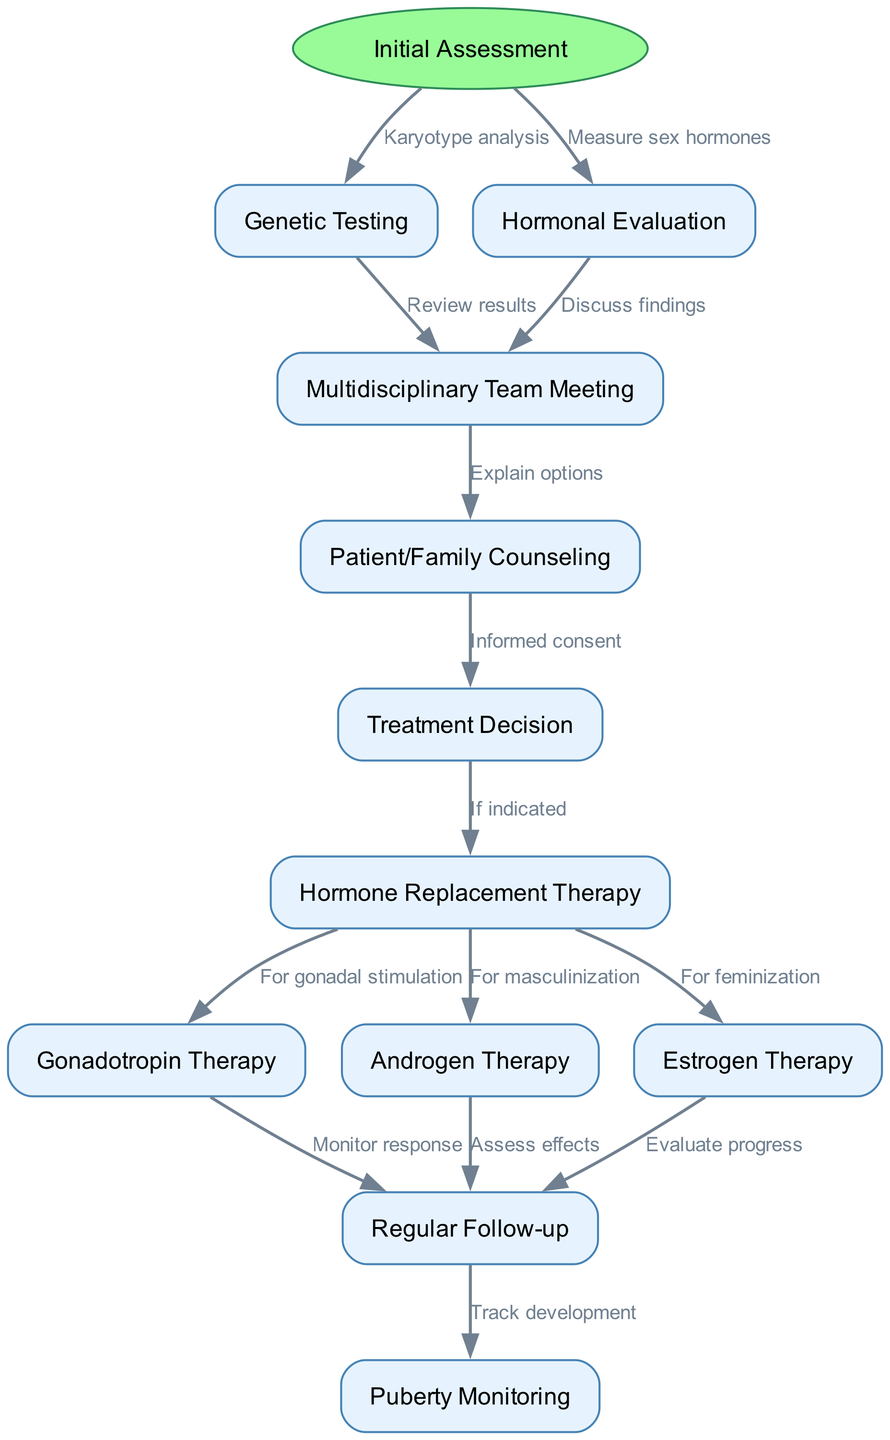What is the starting point of the clinical pathway? The starting point is listed in the diagram as "Initial Assessment," which is the first node and directs toward further evaluations.
Answer: Initial Assessment How many nodes are present in the diagram? By counting the nodes listed in the diagram, there are a total of 11 nodes, including the start node and all the subsequent steps.
Answer: 11 What is the connection between "Genetic Testing" and "Multidisciplinary Team Meeting"? The edge between these two nodes is labeled "Review results," showing a directional flow from genetic testing to the multidisciplinary team meeting.
Answer: Review results What type of therapy is indicated after the "Treatment Decision"? From the "Treatment Decision" node, the diagram shows arrows leading to three types of therapies: Gonadotropin Therapy, Androgen Therapy, and Estrogen Therapy, indicating possible therapies based on individual needs.
Answer: Hormone Replacement Therapy What is the last step in the clinical pathway? The final step listed in the diagram is "Puberty Monitoring," which follows the "Regular Follow-up" and signifies continuous tracking of developmental changes.
Answer: Puberty Monitoring How many types of hormone therapy are indicated in the pathway? The diagram outlines three types of hormone therapy following "Hormone Replacement Therapy": Gonadotropin Therapy, Androgen Therapy, and Estrogen Therapy. Thus, the total is three distinct types.
Answer: 3 What procedure follows the "Hormonal Evaluation"? Following "Hormonal Evaluation," the diagram indicates a flow toward the "Multidisciplinary Team Meeting," suggesting further discussion of the evaluation results.
Answer: Multidisciplinary Team Meeting What is required before making a "Treatment Decision"? The flow indicates that "Patient/Family Counseling" must occur before the "Treatment Decision," highlighting the importance of informed consent and understanding treatment options.
Answer: Patient/Family Counseling What is the purpose of "Regular Follow-up"? The "Regular Follow-up" node is connected to multiple therapeutic branches (Gonadotropin Therapy, Androgen Therapy, Estrogen Therapy) to ensure monitoring of patient response, effects, and progress, indicating the follow-up's extensive role.
Answer: Monitor response, Assess effects, Evaluate progress 